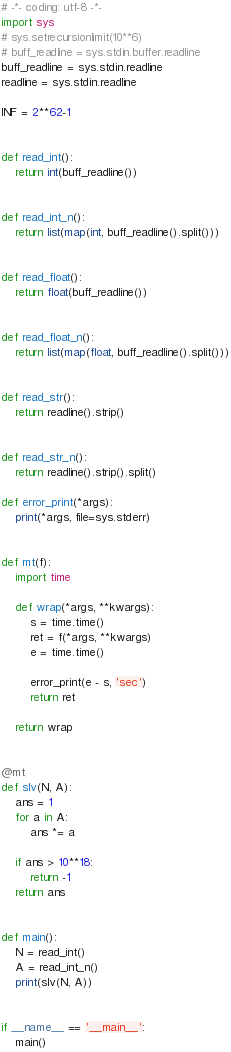<code> <loc_0><loc_0><loc_500><loc_500><_Python_># -*- coding: utf-8 -*-
import sys
# sys.setrecursionlimit(10**6)
# buff_readline = sys.stdin.buffer.readline
buff_readline = sys.stdin.readline
readline = sys.stdin.readline

INF = 2**62-1


def read_int():
    return int(buff_readline())


def read_int_n():
    return list(map(int, buff_readline().split()))


def read_float():
    return float(buff_readline())


def read_float_n():
    return list(map(float, buff_readline().split()))


def read_str():
    return readline().strip()


def read_str_n():
    return readline().strip().split()

def error_print(*args):
    print(*args, file=sys.stderr)


def mt(f):
    import time

    def wrap(*args, **kwargs):
        s = time.time()
        ret = f(*args, **kwargs)
        e = time.time()

        error_print(e - s, 'sec')
        return ret

    return wrap


@mt
def slv(N, A):
    ans = 1
    for a in A:
        ans *= a

    if ans > 10**18:
        return -1
    return ans


def main():
    N = read_int()
    A = read_int_n()
    print(slv(N, A))


if __name__ == '__main__':
    main()
</code> 